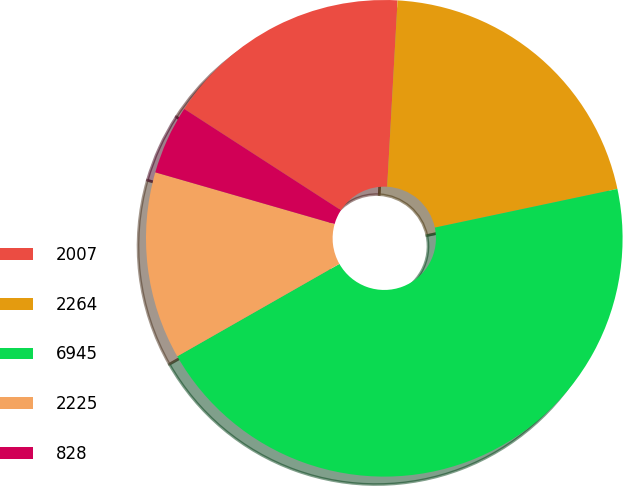<chart> <loc_0><loc_0><loc_500><loc_500><pie_chart><fcel>2007<fcel>2264<fcel>6945<fcel>2225<fcel>828<nl><fcel>16.75%<fcel>20.79%<fcel>45.07%<fcel>12.71%<fcel>4.67%<nl></chart> 